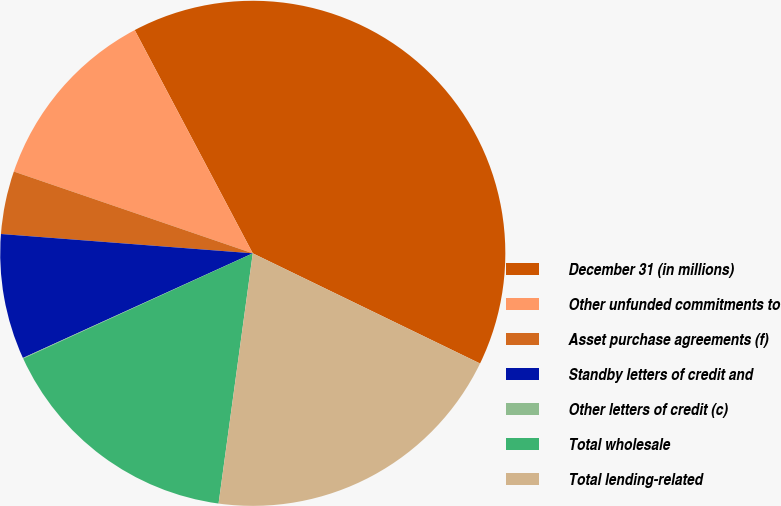<chart> <loc_0><loc_0><loc_500><loc_500><pie_chart><fcel>December 31 (in millions)<fcel>Other unfunded commitments to<fcel>Asset purchase agreements (f)<fcel>Standby letters of credit and<fcel>Other letters of credit (c)<fcel>Total wholesale<fcel>Total lending-related<nl><fcel>39.93%<fcel>12.01%<fcel>4.03%<fcel>8.02%<fcel>0.04%<fcel>16.0%<fcel>19.98%<nl></chart> 